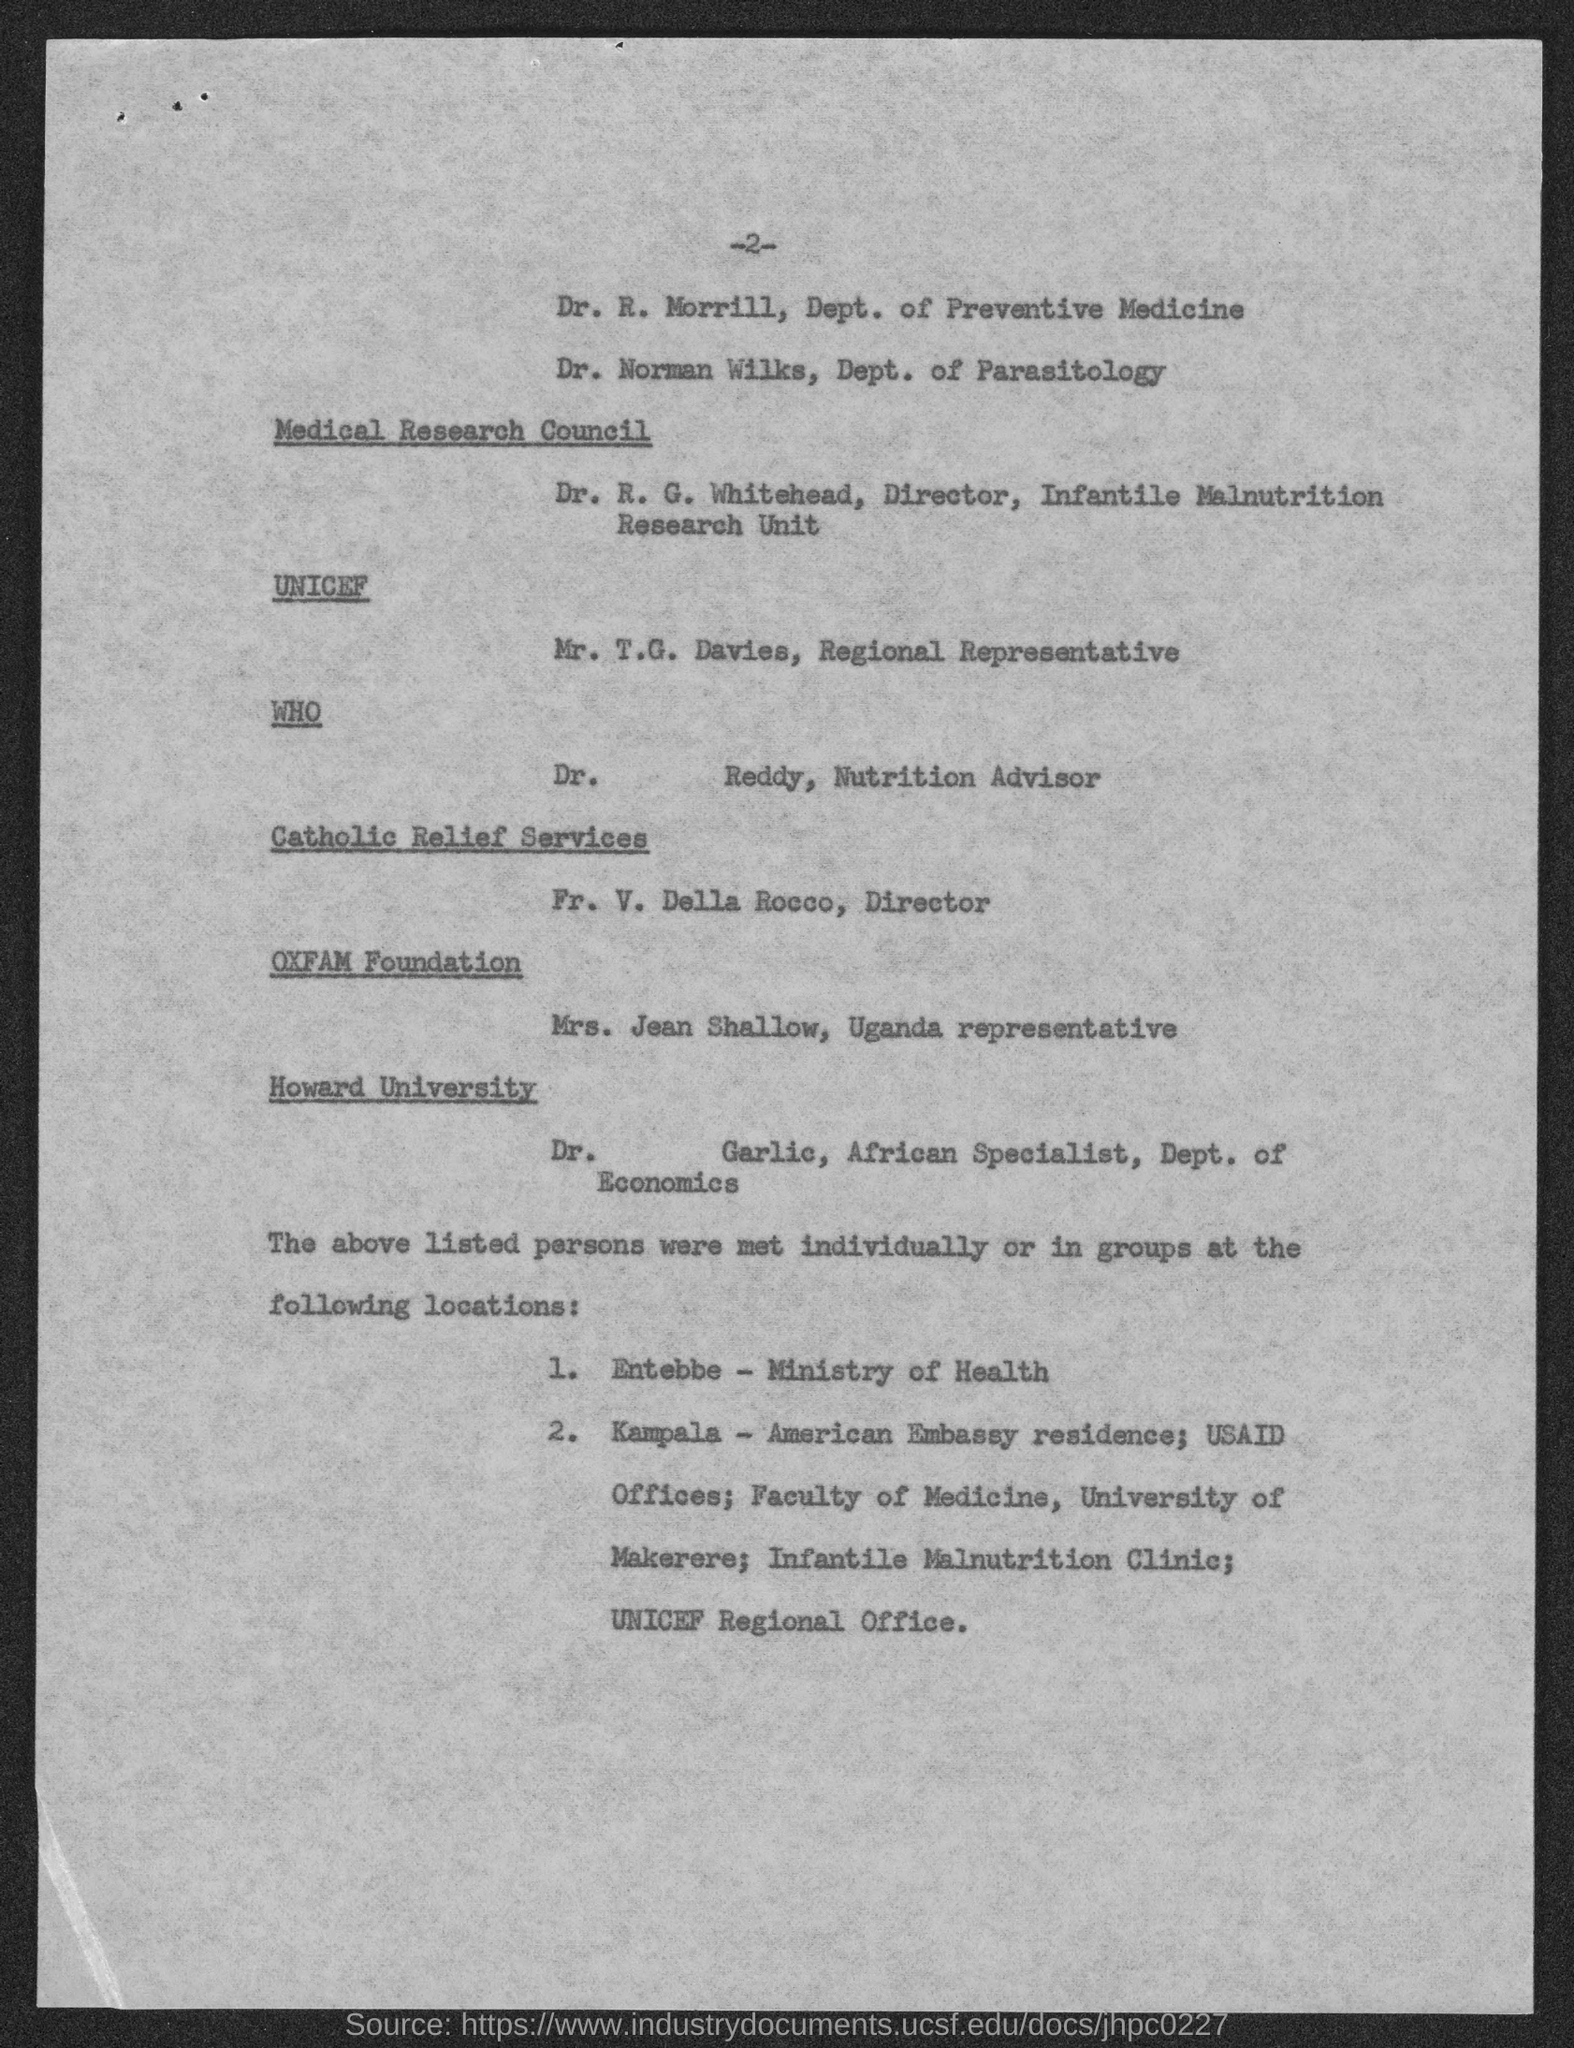Mention a couple of crucial points in this snapshot. Mrs. Jean Shallow is the Uganda representative. Mr. T.G. Davies holds the position of Regional Representative. Dr. R. Morrill belongs to the Department of Preventive Medicine. Fr. V. Della Rocco is the Director. Dr. Reddy is the Nutrition Advisor. 